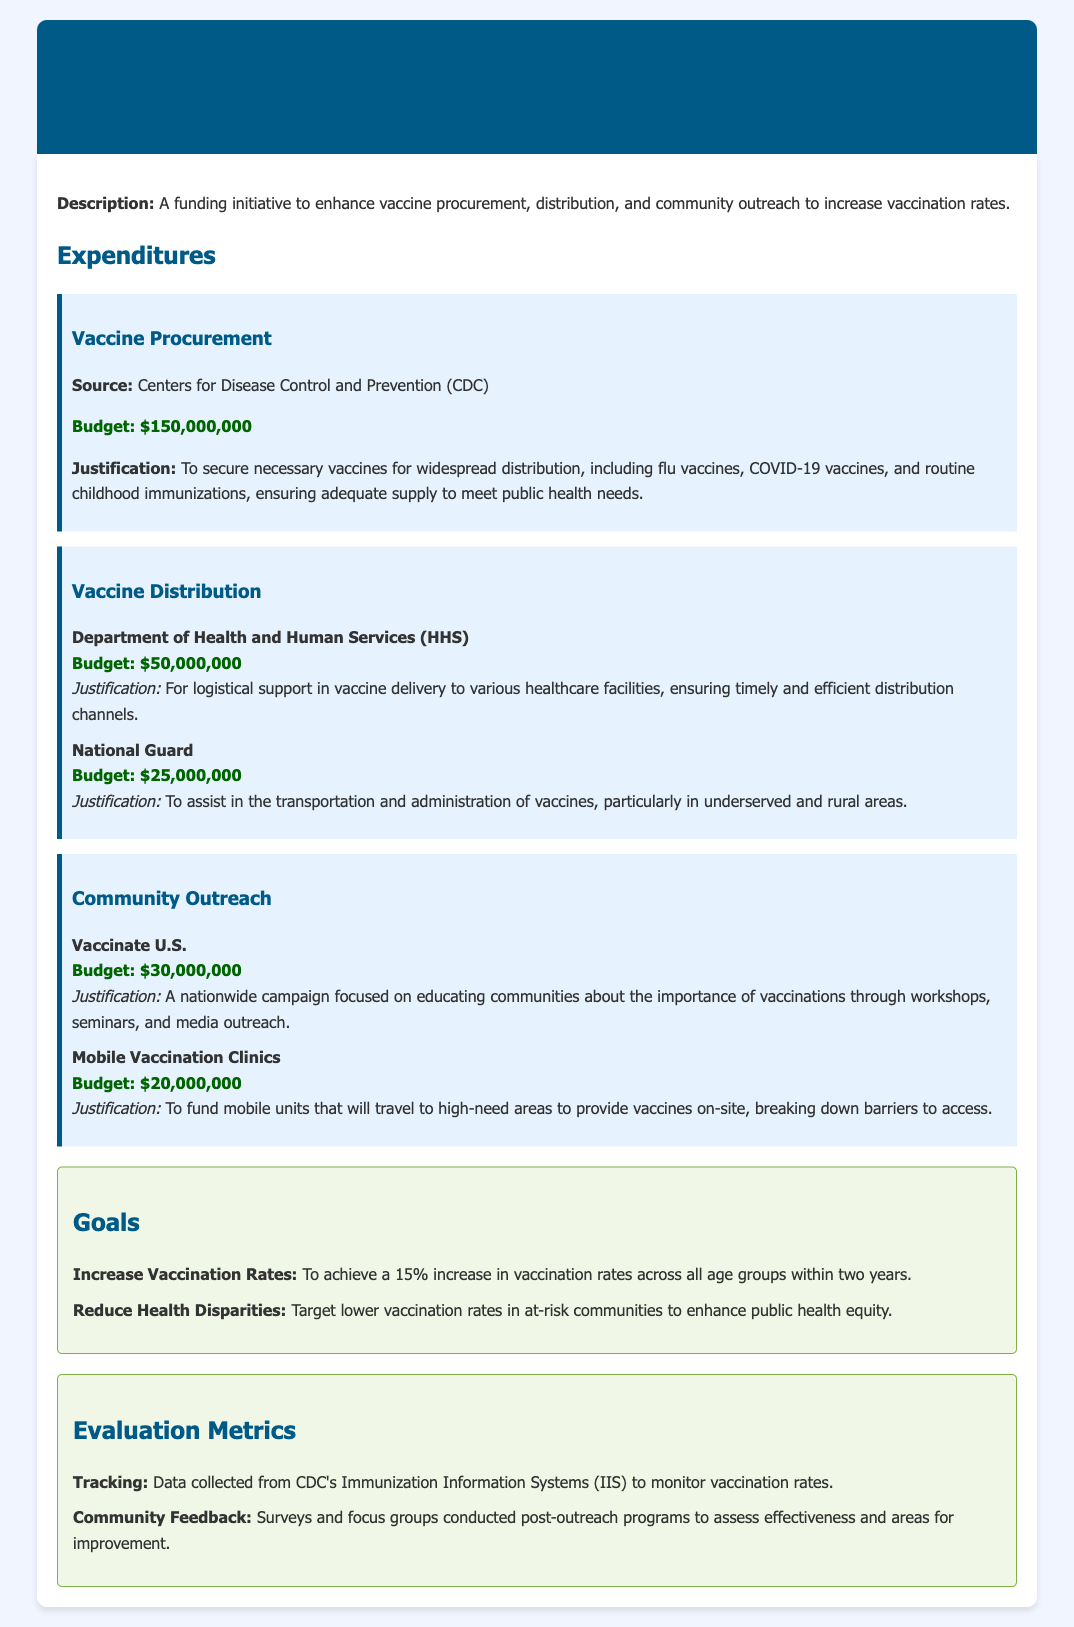What is the total budget for Vaccine Procurement? The total budget for Vaccine Procurement is specified as $150,000,000 in the document.
Answer: $150,000,000 How much is allocated for the National Guard? The document specifies that $25,000,000 is allocated for the National Guard for vaccine transportation and administration.
Answer: $25,000,000 What is the goal for increasing vaccination rates? The goal for increasing vaccination rates is to achieve a 15% increase across all age groups within two years.
Answer: 15% Who is responsible for the community outreach campaign? The organization responsible for the community outreach campaign is Vaccinate U.S. as mentioned in the document.
Answer: Vaccinate U.S What are the evaluation metrics used in this program? The evaluation metrics include tracking vaccination data and gathering community feedback through surveys and focus groups.
Answer: Tracking and Community Feedback What is the budget for Mobile Vaccination Clinics? The budget allocated for Mobile Vaccination Clinics is stated as $20,000,000.
Answer: $20,000,000 Which agency is responsible for logistical support in vaccine delivery? The agency responsible for logistical support in vaccine delivery is the Department of Health and Human Services (HHS).
Answer: Department of Health and Human Services (HHS) What is the main justification for vaccine procurement? The main justification for vaccine procurement is to secure necessary vaccines for widespread distribution to meet public health needs.
Answer: To secure necessary vaccines for widespread distribution How will vaccination rates be monitored? Vaccination rates will be monitored through data collected from CDC's Immunization Information Systems (IIS).
Answer: CDC's Immunization Information Systems (IIS) What type of vaccines are included in the procurement? The types of vaccines included in the procurement are flu vaccines, COVID-19 vaccines, and routine childhood immunizations.
Answer: Flu vaccines, COVID-19 vaccines, and routine childhood immunizations 